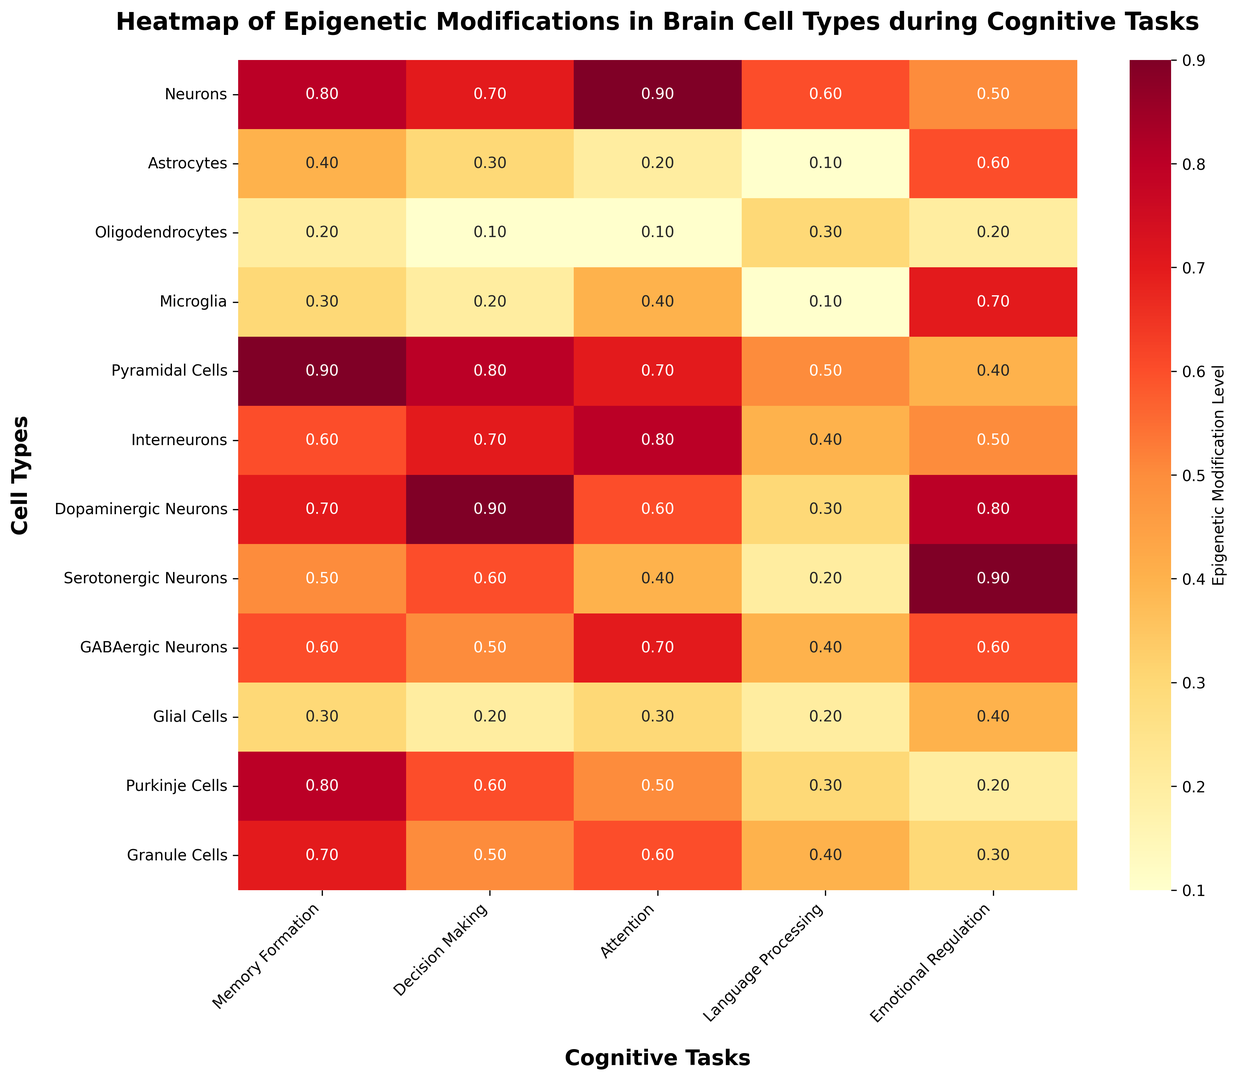Which cell type has the highest level of epigenetic modification during memory formation? By examining the heatmap, look for the cell type with the darkest shade of red in the "Memory Formation" column. The highest value will correspond to the darkest color.
Answer: Pyramidal Cells Which cognitive task shows the greatest epigenetic modification variation across all cell types? To find the task with the greatest variation, observe the range of colors for each cognitive task column and identify the one with the widest range from light yellow to dark red.
Answer: Language Processing What is the difference in epigenetic modification levels for decision making between Neurons and Astrocytes? Locate the values for Neurons and Astrocytes in the "Decision Making" column and subtract the Astrocyte value from the Neuron value: 0.7 - 0.3.
Answer: 0.4 Which cell type exhibits the lowest epigenetic modification level in emotional regulation? Find the lightest shade in the "Emotional Regulation" column and check which cell type it corresponds to.
Answer: Purkinje Cells What is the average epigenetic modification level across all cognitive tasks for GABAergic Neurons? Sum the values for GABAergic Neurons across all cognitive tasks and divide by the number of tasks: (0.6 + 0.5 + 0.7 + 0.4 + 0.6) / 5.
Answer: 0.56 Which cell type has the most balanced epigenetic modification levels across all cognitive tasks, indicated by similar shades across the row? Identify the cell type whose row exhibits the most uniform color pattern, indicating minimal variation in epigenetic modification levels.
Answer: GABAergic Neurons How does the epigenetic modification level during attention compare between Dopaminergic Neurons and Microglia? Compare the values in the "Attention" column for Dopaminergic Neurons and Microglia: 0.6 (Dopaminergic) vs. 0.4 (Microglia).
Answer: Dopaminergic Neurons have a higher level What is the median epigenetic modification level for Pyramidal Cells across all cognitive tasks? Sort the values for Pyramidal Cells (0.9, 0.8, 0.7, 0.5, 0.4) and find the middle value. Since there are five values, the median is the third value.
Answer: 0.7 Which two cell types have the closest epigenetic modification levels for memory formation? Compare the values in the "Memory Formation" column and find two cells with the smallest absolute difference in their values: Granule Cells (0.7) and Dopaminergic Neurons (0.7).
Answer: Granule Cells and Dopaminergic Neurons What is the range of epigenetic modification levels for emotional regulation in the figure? Identify the highest and lowest values in the "Emotional Regulation" column and subtract the lowest value from the highest value: 0.9 (Serotonergic Neurons) - 0.2 (Purkinje Cells).
Answer: 0.7 